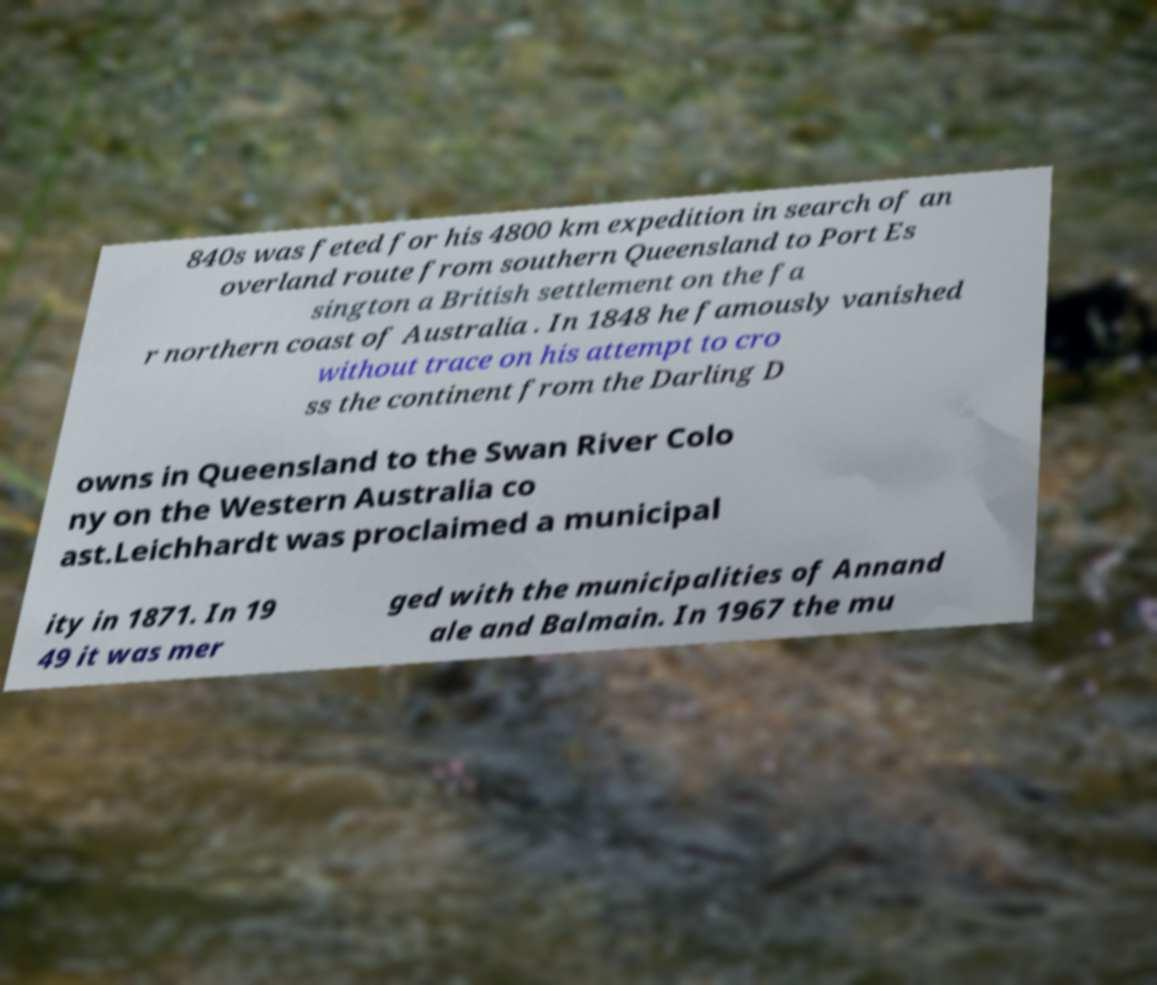For documentation purposes, I need the text within this image transcribed. Could you provide that? 840s was feted for his 4800 km expedition in search of an overland route from southern Queensland to Port Es sington a British settlement on the fa r northern coast of Australia . In 1848 he famously vanished without trace on his attempt to cro ss the continent from the Darling D owns in Queensland to the Swan River Colo ny on the Western Australia co ast.Leichhardt was proclaimed a municipal ity in 1871. In 19 49 it was mer ged with the municipalities of Annand ale and Balmain. In 1967 the mu 